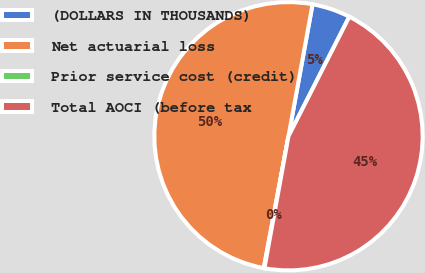Convert chart to OTSL. <chart><loc_0><loc_0><loc_500><loc_500><pie_chart><fcel>(DOLLARS IN THOUSANDS)<fcel>Net actuarial loss<fcel>Prior service cost (credit)<fcel>Total AOCI (before tax<nl><fcel>4.62%<fcel>49.92%<fcel>0.08%<fcel>45.38%<nl></chart> 